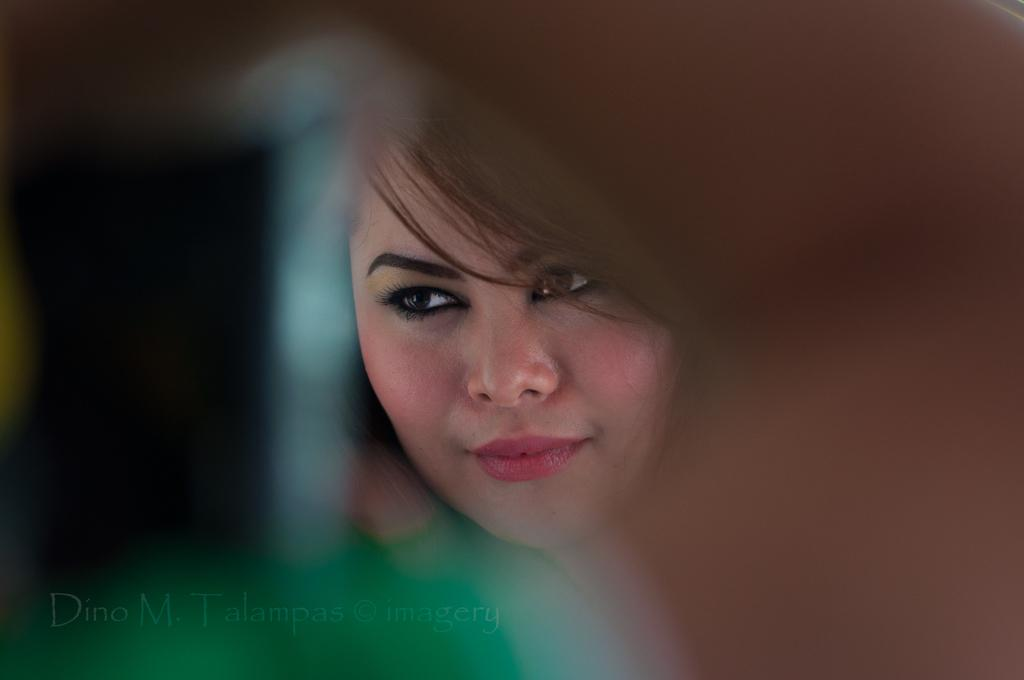What is the main subject of the image? There is a woman's face in the image. How is the image of the woman's face depicted? The image is blurred around the woman's face. What is the taste of the woman's face in the image? The image is not a representation of taste, so it is not possible to determine the taste of the woman's face. 